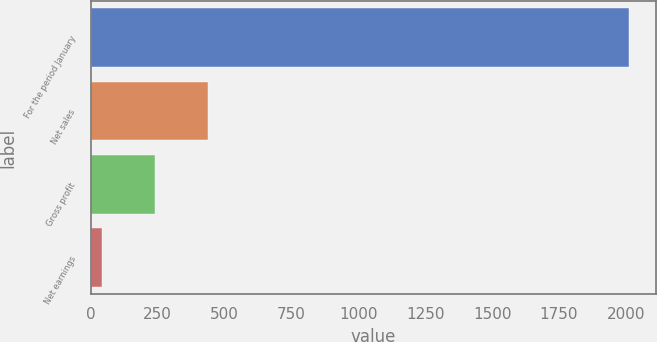Convert chart to OTSL. <chart><loc_0><loc_0><loc_500><loc_500><bar_chart><fcel>For the period January<fcel>Net sales<fcel>Gross profit<fcel>Net earnings<nl><fcel>2012<fcel>436.16<fcel>239.18<fcel>42.2<nl></chart> 